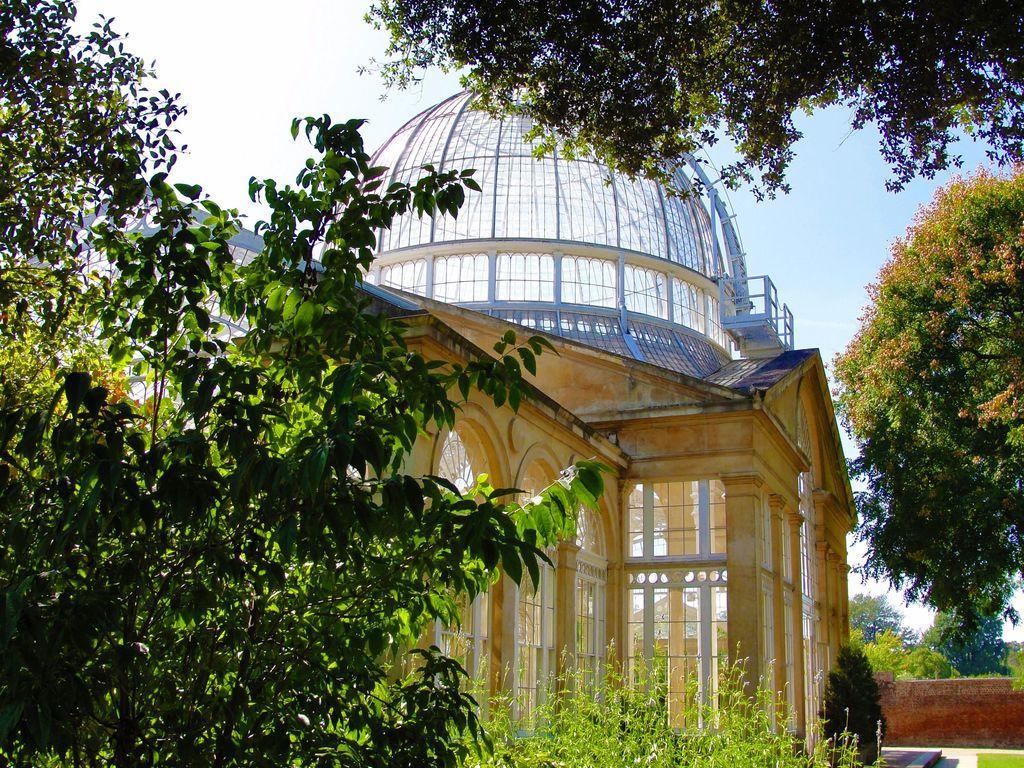Could you give a brief overview of what you see in this image? In the image there are many trees. Behind them there is a building with walls, arches, glasses and roofs. And also there is a small wall. In the background there is sky. 